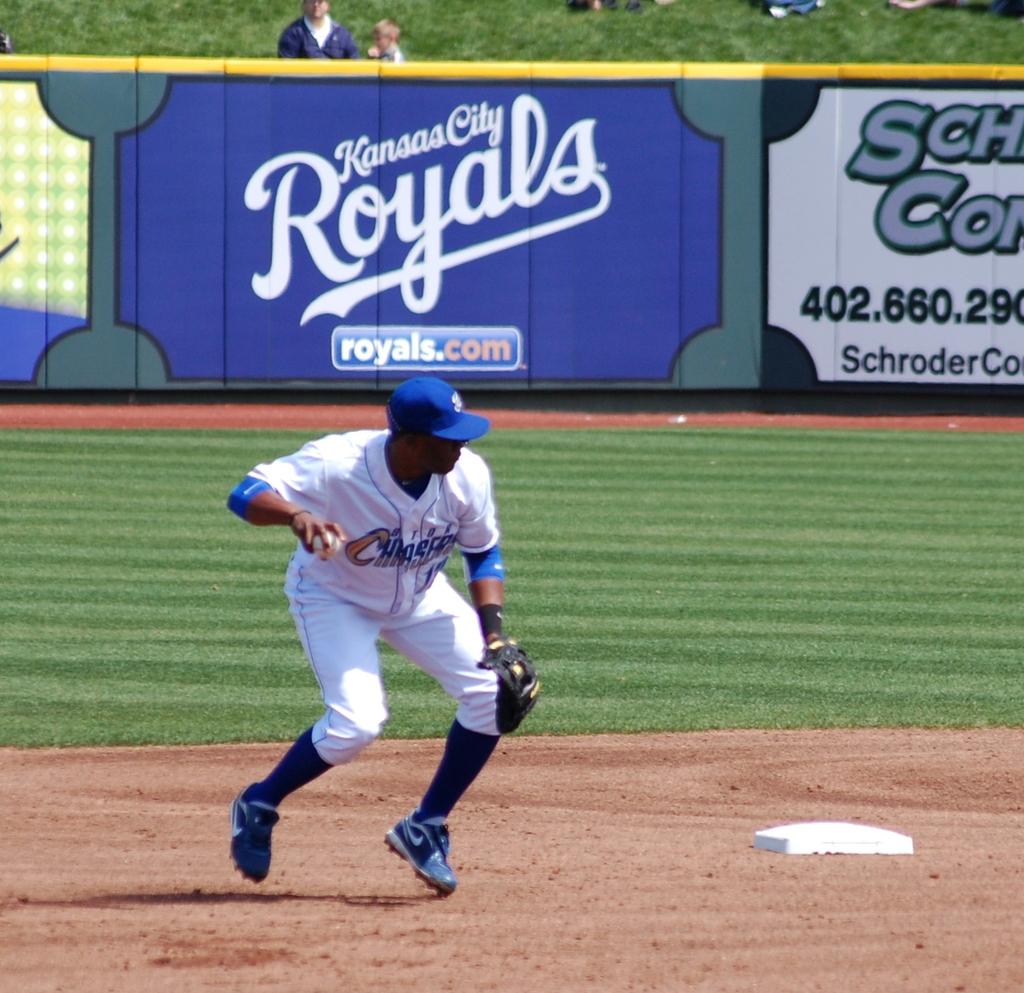What are the first three digits of the phone number on the sign?
Your answer should be compact. 402. What city is the team from?
Offer a terse response. Kansas city. 